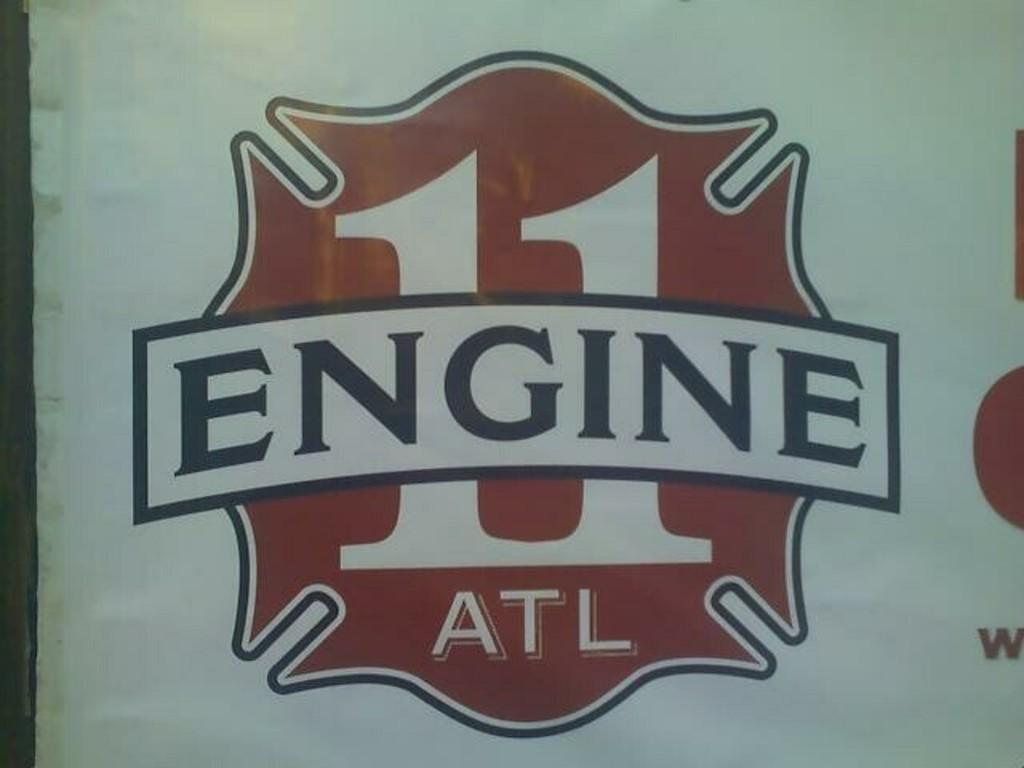<image>
Offer a succinct explanation of the picture presented. red, white and black logo for ATL engine 11 